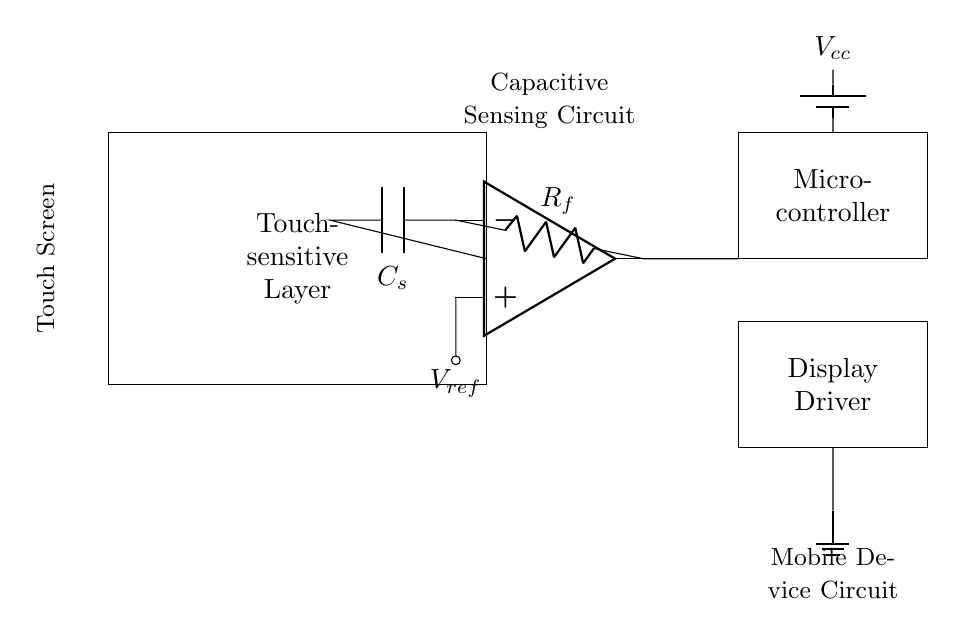What is the main component that detects touch? The main component that detects touch is the touch-sensitive layer, represented as a rectangular box in the circuit diagram. This layer interacts with the user's touch to create a capacitive effect.
Answer: Touch-sensitive Layer What voltage is the reference voltage for the operational amplifier? The reference voltage is denoted as \(V_{ref}\) in the circuit diagram, which is connected to the positive input of the op-amp. This reference voltage is essential for the proper operation of the capacitive sensing circuit.
Answer: \(V_{ref}\) What is the purpose of the capacitor in this circuit? The capacitor, labeled \(C_s\), acts as a sensing element that helps in detecting changes in capacitance when a finger touches the screen. This change in capacitance is then processed by the op-amp to output a corresponding signal.
Answer: Capacitive sensing What is the role of the microcontroller? The microcontroller is responsible for processing the output signal from the capacitive sensor. It interprets the touch detection information and relays it to the display driver for user interaction.
Answer: Processing output How is power supplied to the circuit? Power is supplied by a battery, indicated by the element labeled \(V_{cc}\) in the diagram, which connects to the microcontroller, providing the necessary voltage for circuit operation.
Answer: Battery How does the touch-sensitive layer connect to the capacitive sensor? The touch-sensitive layer connects to the capacitive sensor through wiring that leads directly to the input of the op-amp. This connection allows the capacitive changes detected by the touch-sensitive layer to be amplified and processed.
Answer: Direct connection What type of circuit is represented in this diagram? The circuit is a capacitive sensing circuit, which is used in mobile devices for detecting user interaction through touch on the screen. This specific type of circuit utilizes capacitance measurement to determine touch location.
Answer: Capacitive sensing circuit 